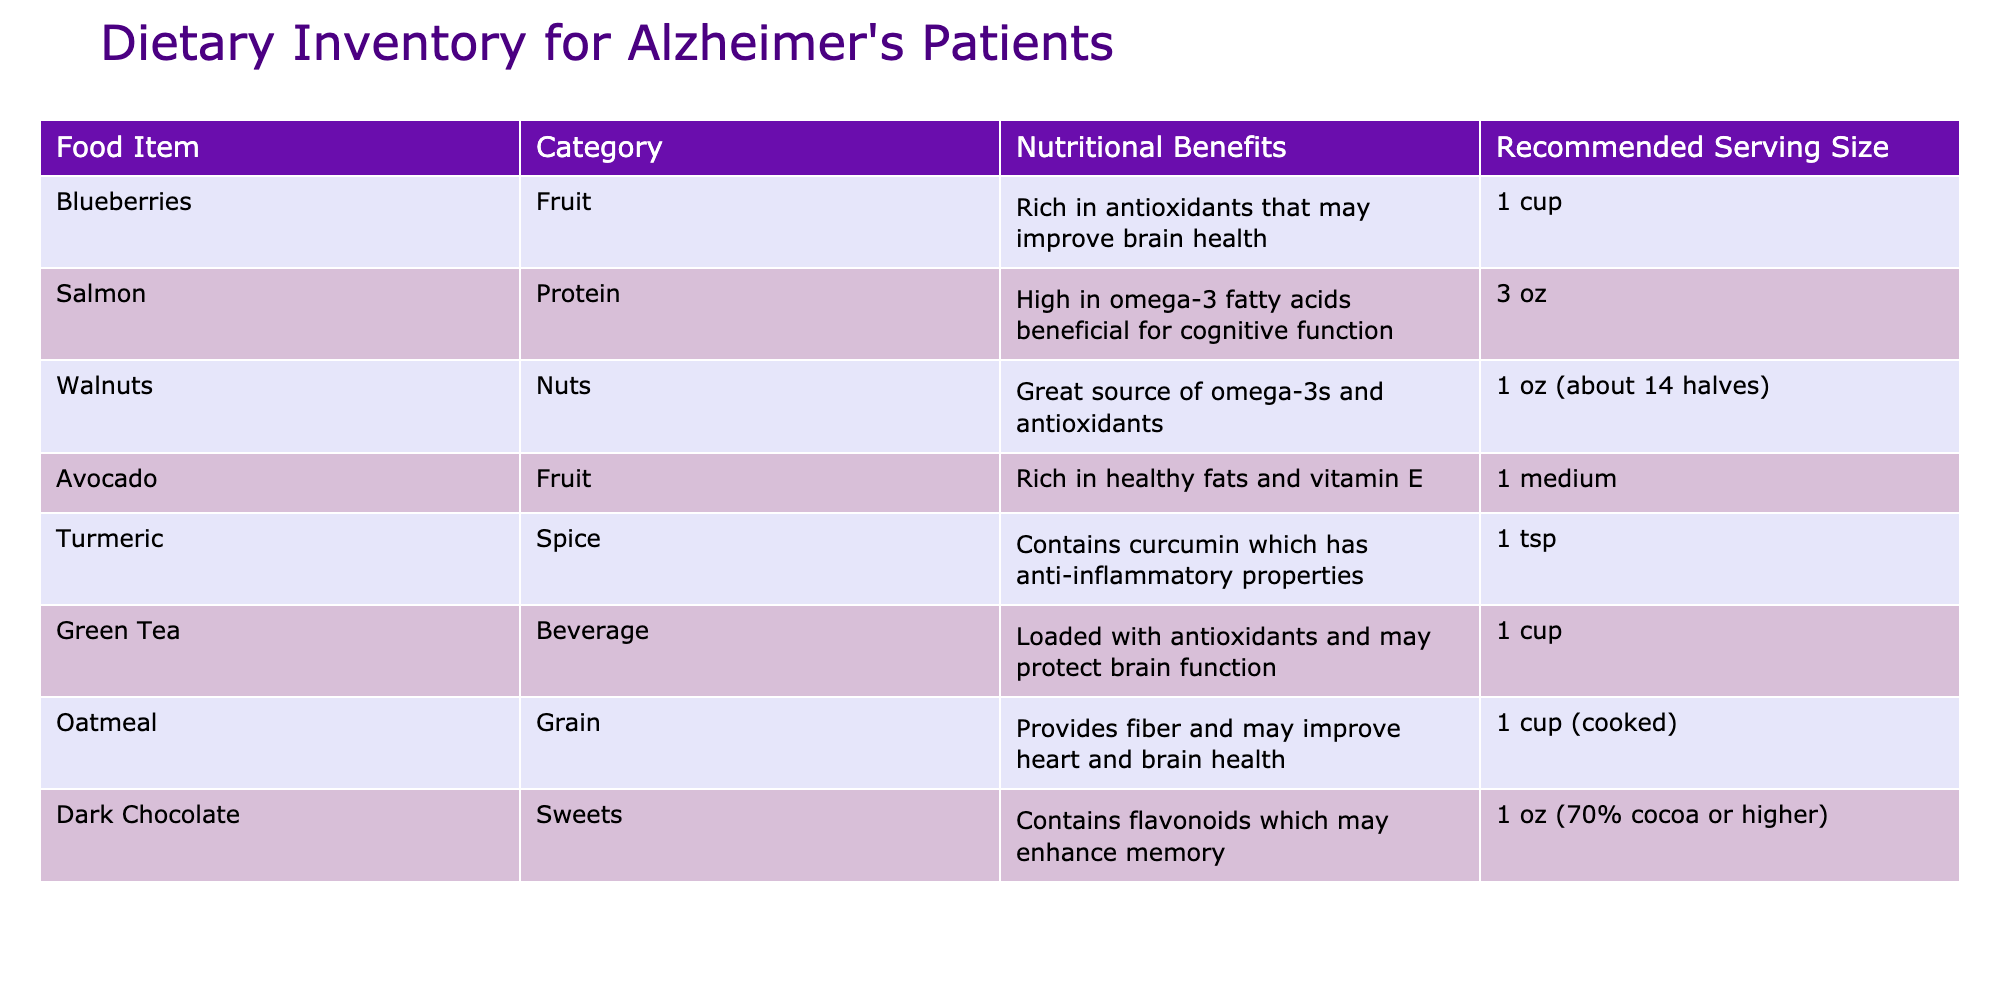What is the recommended serving size of blueberries? The table clearly states that the recommended serving size for blueberries is 1 cup.
Answer: 1 cup Which food item is high in omega-3 fatty acids? The table indicates that salmon and walnuts are both high in omega-3 fatty acids. Salmon is specifically noted for its cognitive benefits.
Answer: Salmon and walnuts What category does turmeric belong to? In the table, turmeric is categorized as a spice, as noted in the 'Category' column.
Answer: Spice True or False: Avocado is listed as a fruit in the table. According to the table, avocado is indeed categorized as a fruit.
Answer: True What are the nutritional benefits of dark chocolate? The table specifies that dark chocolate contains flavonoids which may enhance memory, listed under 'Nutritional Benefits'.
Answer: Contains flavonoids which may enhance memory Which food item has the highest recommended serving size? The recommended serving sizes are compared: 1 cup for blueberries, oatmeal is also 1 cup, and all other items have smaller sizes. Thus, both blueberries and oatmeal have the highest serving sizes.
Answer: Blueberries and oatmeal How many food items in the table are categorized as beverages? The table shows that there is only one item categorized as a beverage, which is green tea.
Answer: 1 What is the total number of food items listed in the table? By counting the rows in the table, we find there are 8 food items listed.
Answer: 8 What is the average recommended serving size for the food items? To find the average, convert the serving sizes to a uniform measure (e.g., cups or ounces). The serving sizes in ounces and cups are: 1 cup (8 oz), 3 oz, 1 oz, 1 medium (considered as 1), 1 tsp (approximately 0.02 oz), and 1 cup (8 oz), half of 1 oz for chocolate and totaling them yields 10.04 ounces. There are 8 items, thus the average serving size is 10.04/8 = 1.26 ounces.
Answer: 1.26 ounces Which foods in the inventory are sources of antioxidants? The table lists blueberries, walnuts, and dark chocolate as foods rich in antioxidants. Analyzing the 'Nutritional Benefits' column, those three are confirmed.
Answer: Blueberries, walnuts, dark chocolate 